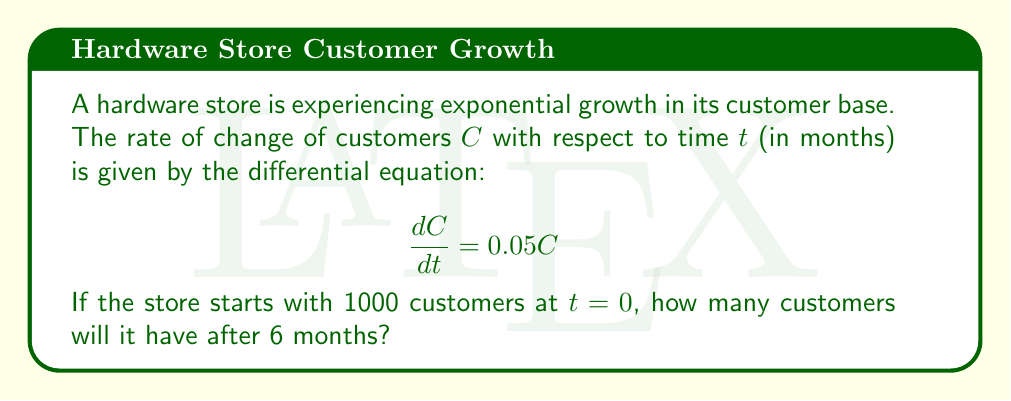Show me your answer to this math problem. To solve this problem, we need to use the exponential growth model for first-order differential equations.

1) The given differential equation is in the form:
   $$\frac{dC}{dt} = kC$$
   where $k = 0.05$ is the growth rate.

2) The general solution for this type of equation is:
   $$C(t) = C_0e^{kt}$$
   where $C_0$ is the initial number of customers.

3) We're given that $C_0 = 1000$ at $t=0$, so we can write:
   $$C(t) = 1000e^{0.05t}$$

4) To find the number of customers after 6 months, we substitute $t=6$ into our equation:
   $$C(6) = 1000e^{0.05(6)}$$

5) Simplify:
   $$C(6) = 1000e^{0.3}$$

6) Calculate:
   $$C(6) = 1000 \times 1.3498588$$
   $$C(6) = 1349.8588$$

7) Rounding to the nearest whole number (as we can't have a fraction of a customer):
   $$C(6) \approx 1350$$

Therefore, after 6 months, the hardware store will have approximately 1350 customers.
Answer: 1350 customers 